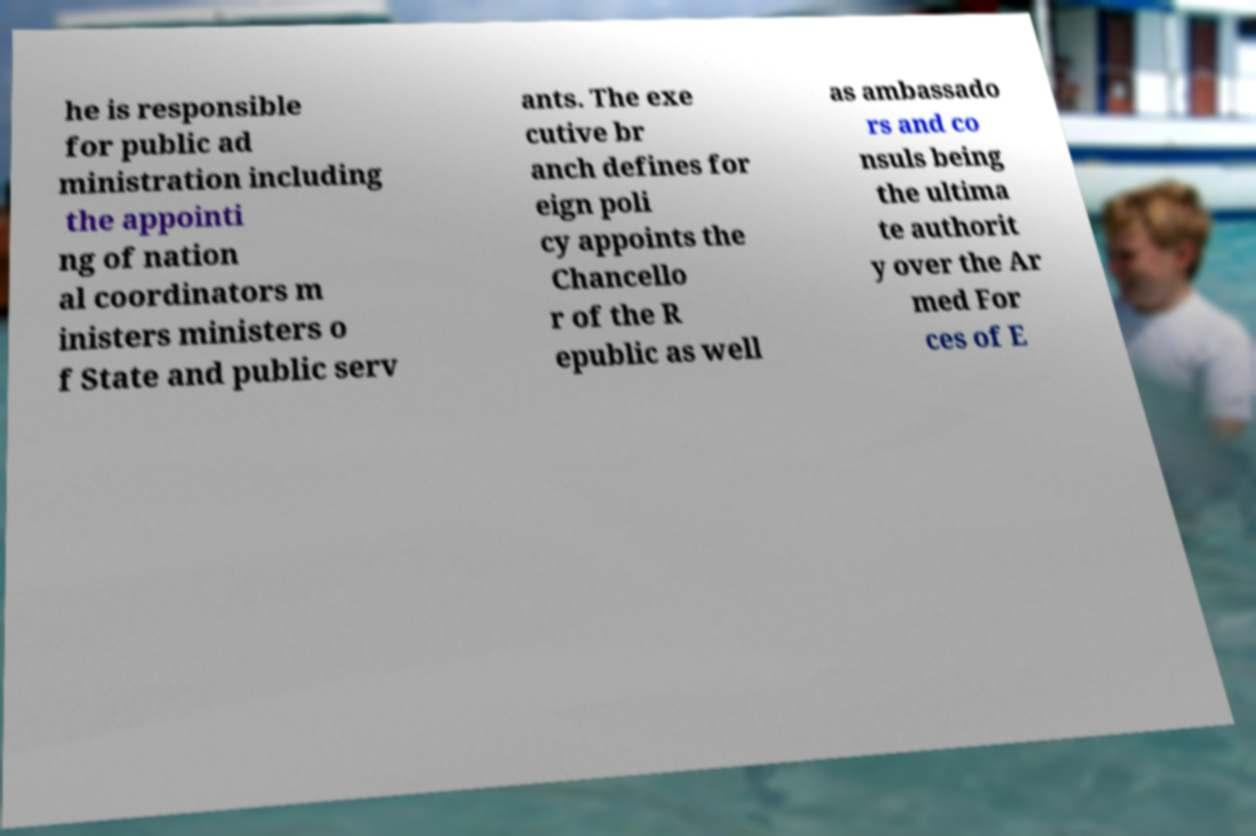There's text embedded in this image that I need extracted. Can you transcribe it verbatim? he is responsible for public ad ministration including the appointi ng of nation al coordinators m inisters ministers o f State and public serv ants. The exe cutive br anch defines for eign poli cy appoints the Chancello r of the R epublic as well as ambassado rs and co nsuls being the ultima te authorit y over the Ar med For ces of E 